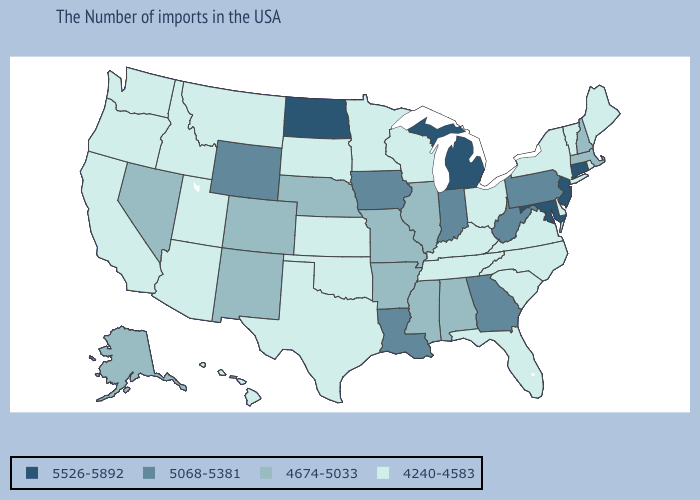Which states hav the highest value in the Northeast?
Write a very short answer. Connecticut, New Jersey. Does Idaho have a lower value than Montana?
Give a very brief answer. No. Which states have the lowest value in the USA?
Give a very brief answer. Maine, Rhode Island, Vermont, New York, Delaware, Virginia, North Carolina, South Carolina, Ohio, Florida, Kentucky, Tennessee, Wisconsin, Minnesota, Kansas, Oklahoma, Texas, South Dakota, Utah, Montana, Arizona, Idaho, California, Washington, Oregon, Hawaii. What is the value of Alabama?
Quick response, please. 4674-5033. What is the lowest value in the Northeast?
Write a very short answer. 4240-4583. Name the states that have a value in the range 4240-4583?
Be succinct. Maine, Rhode Island, Vermont, New York, Delaware, Virginia, North Carolina, South Carolina, Ohio, Florida, Kentucky, Tennessee, Wisconsin, Minnesota, Kansas, Oklahoma, Texas, South Dakota, Utah, Montana, Arizona, Idaho, California, Washington, Oregon, Hawaii. Is the legend a continuous bar?
Write a very short answer. No. What is the value of Wisconsin?
Keep it brief. 4240-4583. Name the states that have a value in the range 5526-5892?
Concise answer only. Connecticut, New Jersey, Maryland, Michigan, North Dakota. What is the highest value in the USA?
Give a very brief answer. 5526-5892. What is the value of Colorado?
Short answer required. 4674-5033. What is the lowest value in states that border Delaware?
Concise answer only. 5068-5381. Name the states that have a value in the range 4240-4583?
Write a very short answer. Maine, Rhode Island, Vermont, New York, Delaware, Virginia, North Carolina, South Carolina, Ohio, Florida, Kentucky, Tennessee, Wisconsin, Minnesota, Kansas, Oklahoma, Texas, South Dakota, Utah, Montana, Arizona, Idaho, California, Washington, Oregon, Hawaii. Among the states that border Kansas , does Missouri have the highest value?
Answer briefly. Yes. Name the states that have a value in the range 5068-5381?
Give a very brief answer. Pennsylvania, West Virginia, Georgia, Indiana, Louisiana, Iowa, Wyoming. 